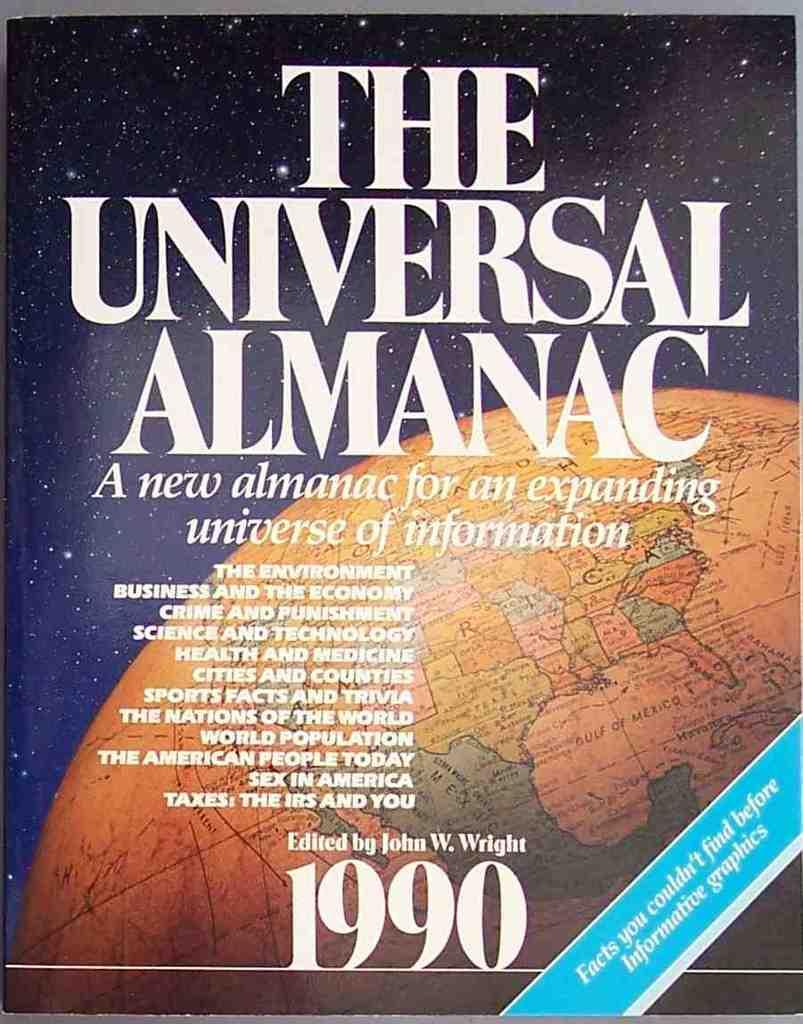<image>
Relay a brief, clear account of the picture shown. The Universal Almanac from 1990 was edited by John W. Wright. 